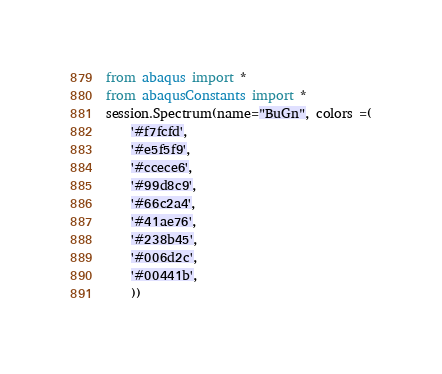<code> <loc_0><loc_0><loc_500><loc_500><_Python_>from abaqus import *
from abaqusConstants import *
session.Spectrum(name="BuGn", colors =(
    '#f7fcfd',
    '#e5f5f9',
    '#ccece6',
    '#99d8c9',
    '#66c2a4',
    '#41ae76',
    '#238b45',
    '#006d2c',
    '#00441b',
    ))
</code> 